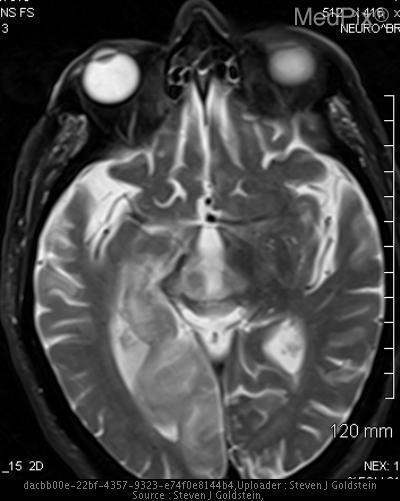Is there any hemorrhage?
Quick response, please. No. What are these hyperintensities to the right?
Be succinct. Infarcted areas. Is the brain atrophied or shrunk?
Give a very brief answer. No. 